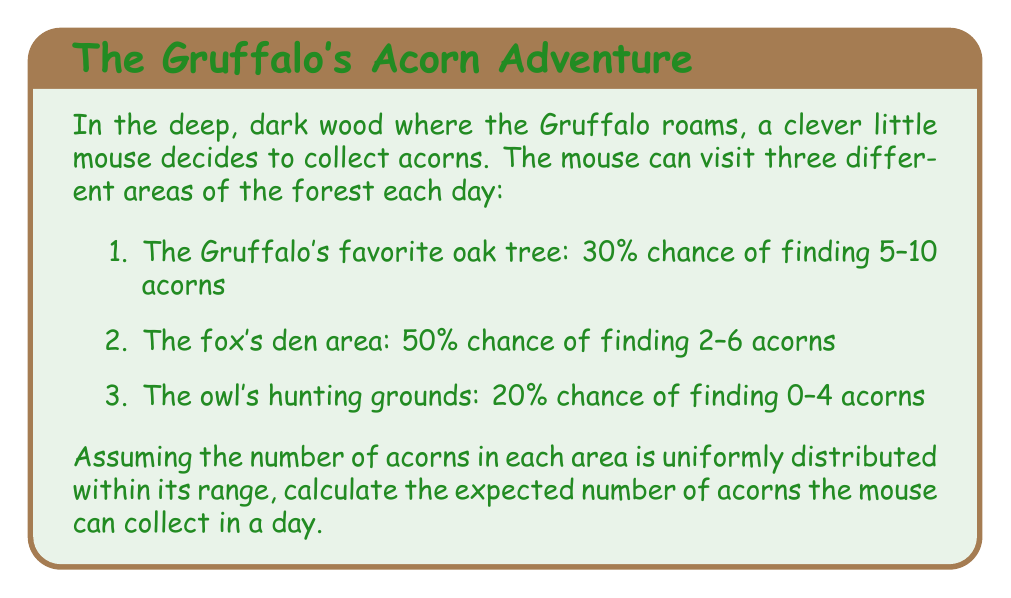Show me your answer to this math problem. Let's approach this step-by-step:

1) First, we need to calculate the expected number of acorns for each area:

   a) Gruffalo's oak tree:
      Range: 5-10 acorns
      Expected value = $\frac{5 + 10}{2} = 7.5$ acorns

   b) Fox's den area:
      Range: 2-6 acorns
      Expected value = $\frac{2 + 6}{2} = 4$ acorns

   c) Owl's hunting grounds:
      Range: 0-4 acorns
      Expected value = $\frac{0 + 4}{2} = 2$ acorns

2) Now, we need to consider the probability of visiting each area:

   Gruffalo's oak tree: 30% = 0.3
   Fox's den area: 50% = 0.5
   Owl's hunting grounds: 20% = 0.2

3) The expected number of acorns is the sum of each area's expected value multiplied by its probability:

   $E(\text{acorns}) = (7.5 \times 0.3) + (4 \times 0.5) + (2 \times 0.2)$

4) Let's calculate:

   $E(\text{acorns}) = 2.25 + 2 + 0.4 = 4.65$

Therefore, the expected number of acorns the mouse can collect in a day is 4.65.
Answer: 4.65 acorns 